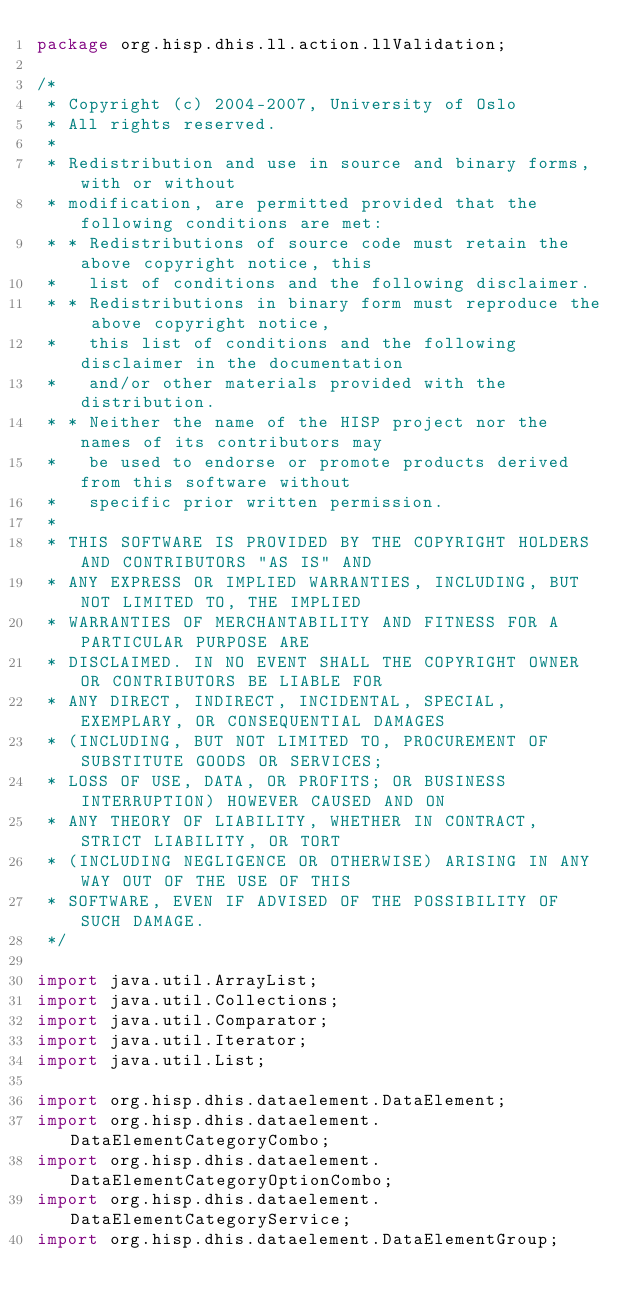Convert code to text. <code><loc_0><loc_0><loc_500><loc_500><_Java_>package org.hisp.dhis.ll.action.llValidation;

/*
 * Copyright (c) 2004-2007, University of Oslo
 * All rights reserved.
 *
 * Redistribution and use in source and binary forms, with or without
 * modification, are permitted provided that the following conditions are met:
 * * Redistributions of source code must retain the above copyright notice, this
 *   list of conditions and the following disclaimer.
 * * Redistributions in binary form must reproduce the above copyright notice,
 *   this list of conditions and the following disclaimer in the documentation
 *   and/or other materials provided with the distribution.
 * * Neither the name of the HISP project nor the names of its contributors may
 *   be used to endorse or promote products derived from this software without
 *   specific prior written permission.
 *
 * THIS SOFTWARE IS PROVIDED BY THE COPYRIGHT HOLDERS AND CONTRIBUTORS "AS IS" AND
 * ANY EXPRESS OR IMPLIED WARRANTIES, INCLUDING, BUT NOT LIMITED TO, THE IMPLIED
 * WARRANTIES OF MERCHANTABILITY AND FITNESS FOR A PARTICULAR PURPOSE ARE
 * DISCLAIMED. IN NO EVENT SHALL THE COPYRIGHT OWNER OR CONTRIBUTORS BE LIABLE FOR
 * ANY DIRECT, INDIRECT, INCIDENTAL, SPECIAL, EXEMPLARY, OR CONSEQUENTIAL DAMAGES
 * (INCLUDING, BUT NOT LIMITED TO, PROCUREMENT OF SUBSTITUTE GOODS OR SERVICES;
 * LOSS OF USE, DATA, OR PROFITS; OR BUSINESS INTERRUPTION) HOWEVER CAUSED AND ON
 * ANY THEORY OF LIABILITY, WHETHER IN CONTRACT, STRICT LIABILITY, OR TORT
 * (INCLUDING NEGLIGENCE OR OTHERWISE) ARISING IN ANY WAY OUT OF THE USE OF THIS
 * SOFTWARE, EVEN IF ADVISED OF THE POSSIBILITY OF SUCH DAMAGE.
 */

import java.util.ArrayList;
import java.util.Collections;
import java.util.Comparator;
import java.util.Iterator;
import java.util.List;

import org.hisp.dhis.dataelement.DataElement;
import org.hisp.dhis.dataelement.DataElementCategoryCombo;
import org.hisp.dhis.dataelement.DataElementCategoryOptionCombo;
import org.hisp.dhis.dataelement.DataElementCategoryService;
import org.hisp.dhis.dataelement.DataElementGroup;</code> 